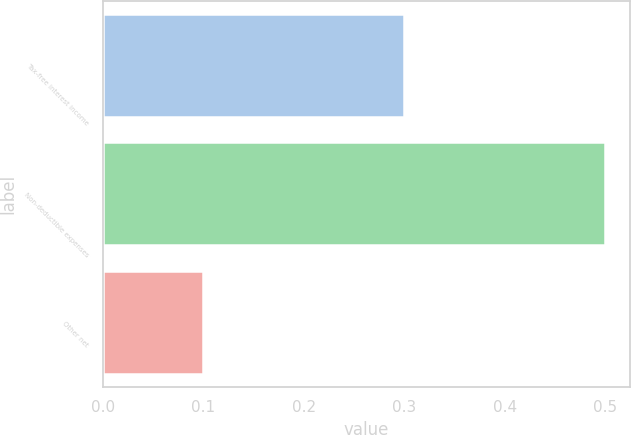<chart> <loc_0><loc_0><loc_500><loc_500><bar_chart><fcel>Tax-free interest income<fcel>Non-deductible expenses<fcel>Other net<nl><fcel>0.3<fcel>0.5<fcel>0.1<nl></chart> 